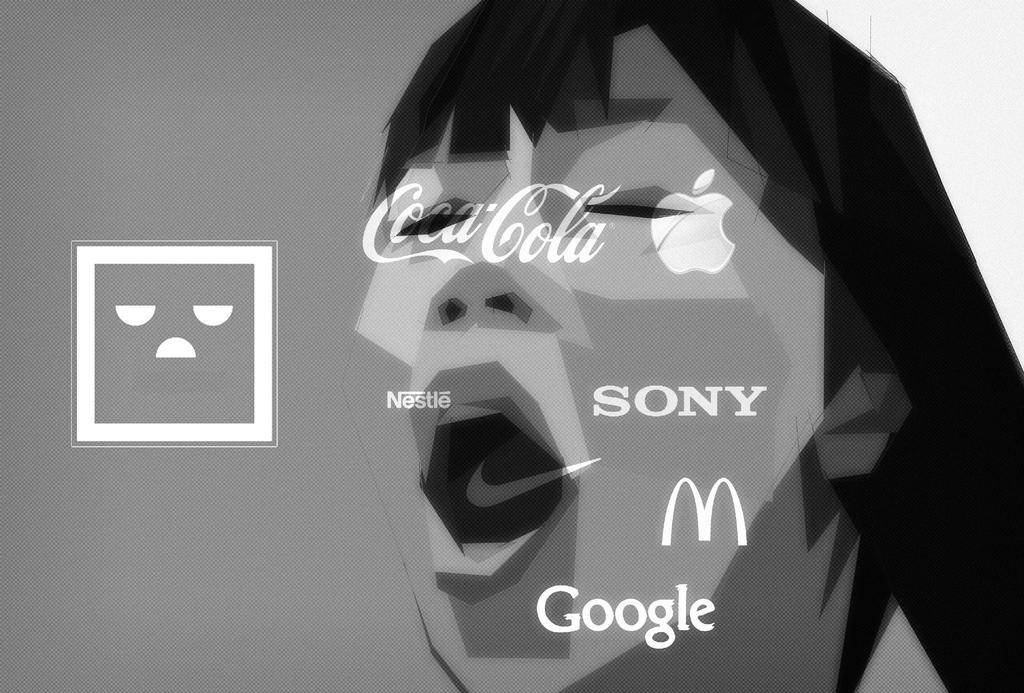Please provide a concise description of this image. This image is a graphical image. In this image there is a text and there are a few symbols and there is an image of a human on it. 